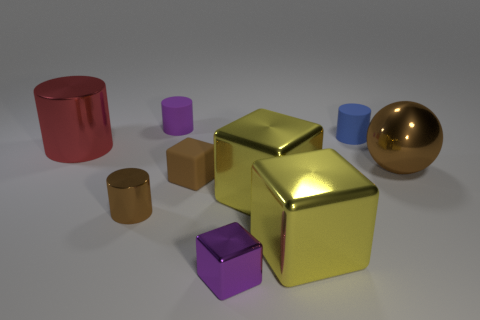How many other objects are there of the same shape as the purple matte thing?
Your response must be concise. 3. There is a small blue rubber thing; is its shape the same as the brown metal object that is on the left side of the tiny blue object?
Make the answer very short. Yes. There is a brown object that is the same shape as the red shiny object; what is its material?
Provide a succinct answer. Metal. What number of large objects are purple matte objects or blocks?
Your answer should be very brief. 2. Are there fewer yellow shiny cubes left of the brown cylinder than tiny cylinders that are to the right of the purple metal cube?
Offer a terse response. Yes. How many things are either big cylinders or gray cylinders?
Make the answer very short. 1. How many tiny brown blocks are in front of the small metallic block?
Keep it short and to the point. 0. Does the tiny metallic cube have the same color as the large metallic cylinder?
Your answer should be very brief. No. What shape is the brown object that is made of the same material as the brown ball?
Keep it short and to the point. Cylinder. Do the small thing that is to the left of the tiny purple rubber cylinder and the tiny blue thing have the same shape?
Offer a terse response. Yes. 